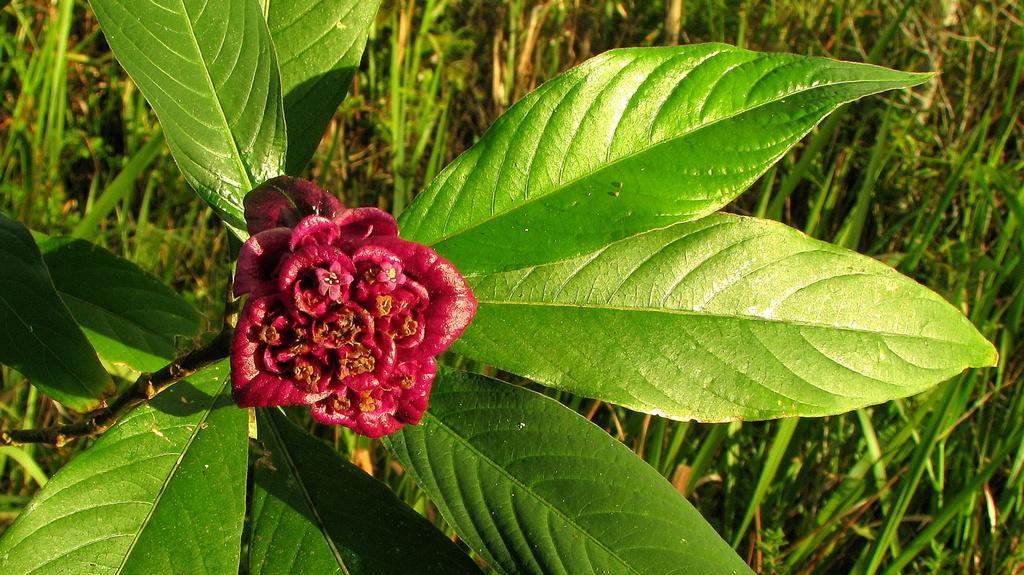Can you describe this image briefly? In this picture I can see there is a red color flower attached to the plant and there are few leaves, there is some grass in the backdrop. 